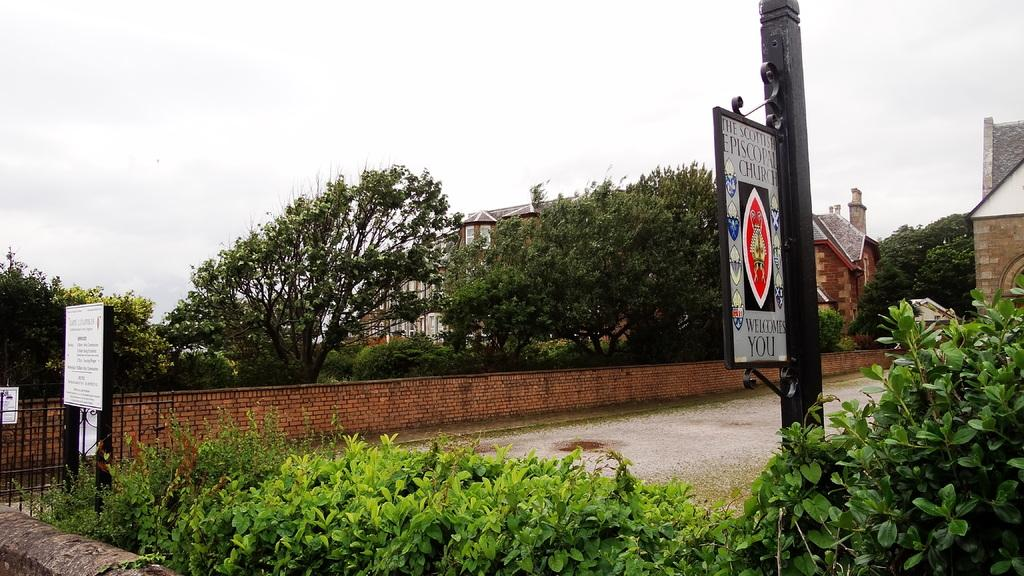What type of structures can be seen in the image? There are houses in the image. What other natural elements are present in the image? There are plants, trees, and the sky visible in the image. Is there any man-made object that serves as an entrance or boundary? Yes, there is a gate in the image. Are there any signs or messages displayed in the image? Yes, there are boards with text written on them in the image. What other architectural feature can be seen in the image? There is a wall in the image. Can you tell me how many needles are sticking out of the trees in the image? There are no needles present in the image; the trees have leaves. What type of lipstick is the person wearing in the image? There is no person present in the image, so it is not possible to determine what type of lipstick they might be wearing. 